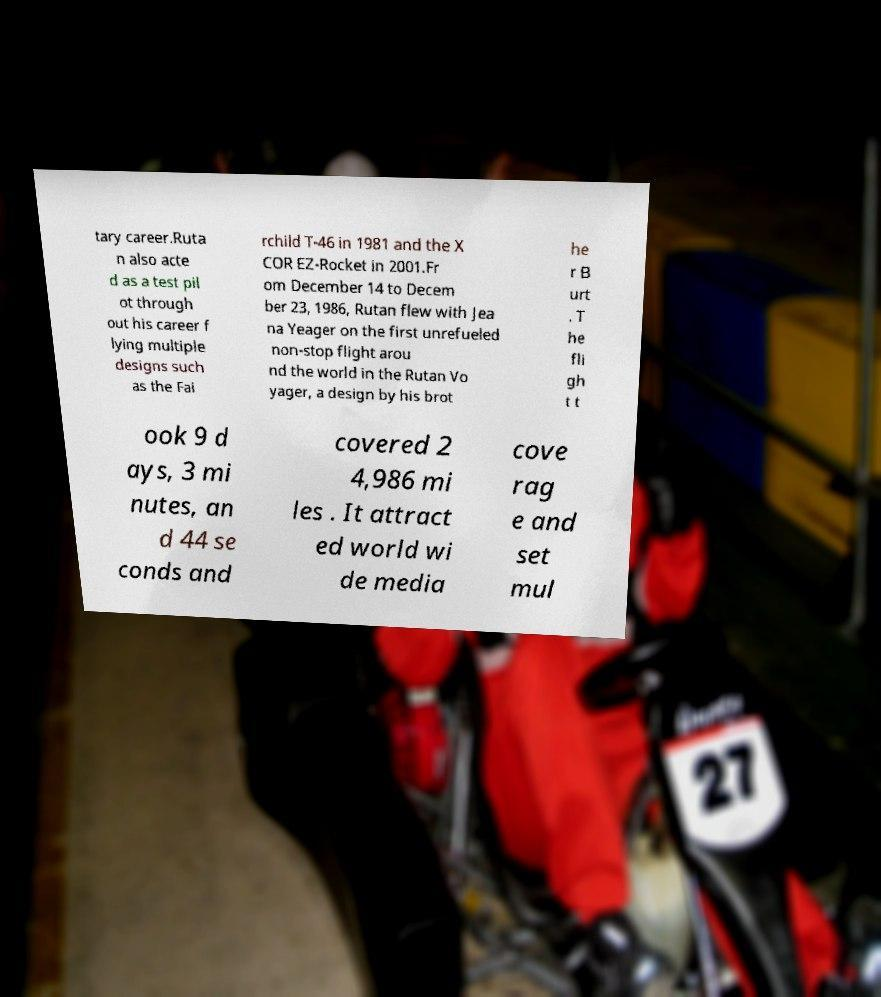Can you accurately transcribe the text from the provided image for me? tary career.Ruta n also acte d as a test pil ot through out his career f lying multiple designs such as the Fai rchild T-46 in 1981 and the X COR EZ-Rocket in 2001.Fr om December 14 to Decem ber 23, 1986, Rutan flew with Jea na Yeager on the first unrefueled non-stop flight arou nd the world in the Rutan Vo yager, a design by his brot he r B urt . T he fli gh t t ook 9 d ays, 3 mi nutes, an d 44 se conds and covered 2 4,986 mi les . It attract ed world wi de media cove rag e and set mul 